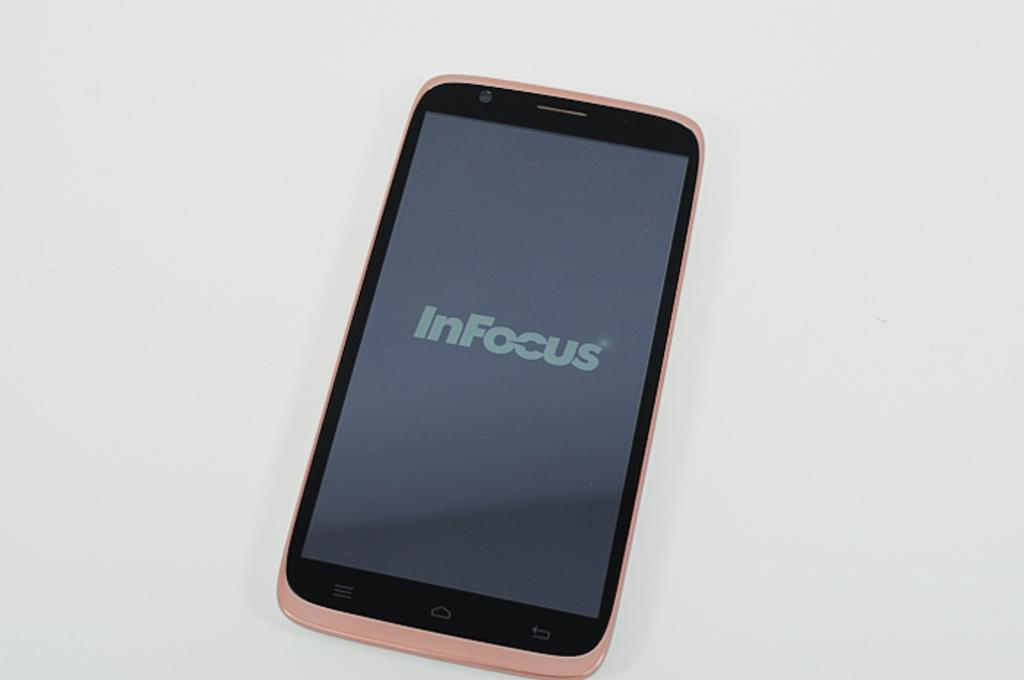What is the main object in the center of the image? There is a phone in the center of the image. What color is the background of the image? The background of the image is white. What type of bells can be heard ringing in the image? There are no bells present in the image, and therefore no sound can be heard. 